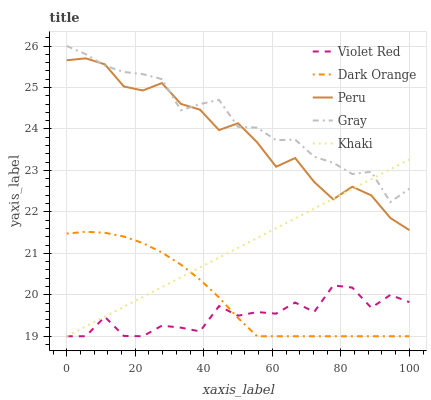Does Violet Red have the minimum area under the curve?
Answer yes or no. Yes. Does Gray have the maximum area under the curve?
Answer yes or no. Yes. Does Khaki have the minimum area under the curve?
Answer yes or no. No. Does Khaki have the maximum area under the curve?
Answer yes or no. No. Is Khaki the smoothest?
Answer yes or no. Yes. Is Violet Red the roughest?
Answer yes or no. Yes. Is Violet Red the smoothest?
Answer yes or no. No. Is Khaki the roughest?
Answer yes or no. No. Does Dark Orange have the lowest value?
Answer yes or no. Yes. Does Peru have the lowest value?
Answer yes or no. No. Does Gray have the highest value?
Answer yes or no. Yes. Does Khaki have the highest value?
Answer yes or no. No. Is Violet Red less than Gray?
Answer yes or no. Yes. Is Gray greater than Violet Red?
Answer yes or no. Yes. Does Peru intersect Khaki?
Answer yes or no. Yes. Is Peru less than Khaki?
Answer yes or no. No. Is Peru greater than Khaki?
Answer yes or no. No. Does Violet Red intersect Gray?
Answer yes or no. No. 